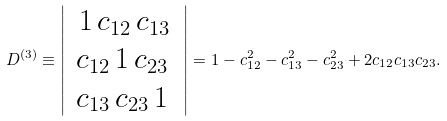<formula> <loc_0><loc_0><loc_500><loc_500>D ^ { ( 3 ) } \equiv \left | \begin{array} { c } { \, 1 \, c _ { 1 2 } \, c _ { 1 3 } \, } \\ { c _ { 1 2 } \, 1 \, c _ { 2 3 } \, } \\ { c _ { 1 3 } \, c _ { 2 3 } \, 1 \, } \\ \end{array} \right | = 1 - c _ { 1 2 } ^ { 2 } - c _ { 1 3 } ^ { 2 } - c _ { 2 3 } ^ { 2 } + 2 c _ { 1 2 } c _ { 1 3 } c _ { 2 3 } .</formula> 